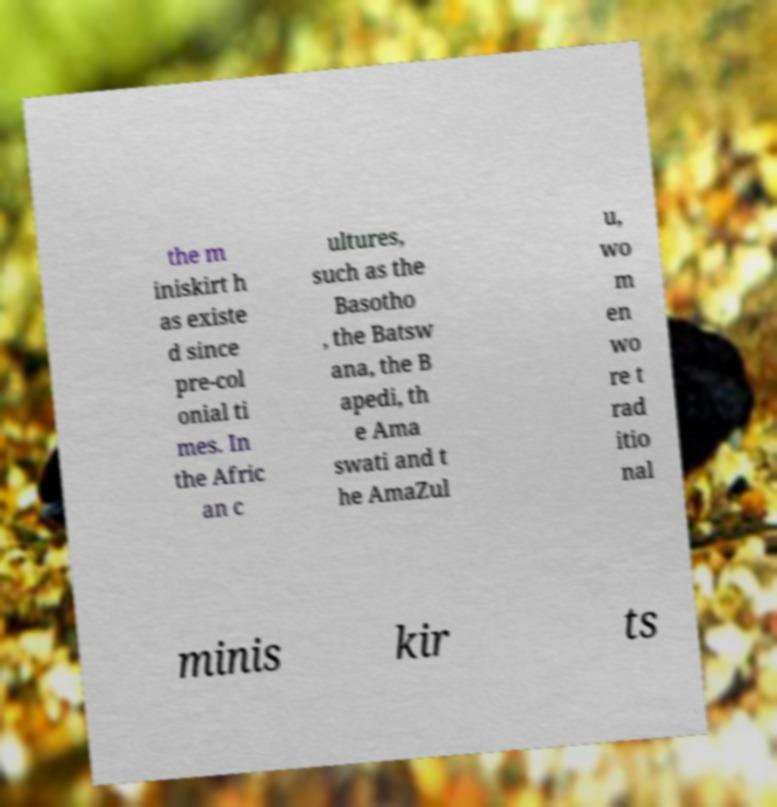What messages or text are displayed in this image? I need them in a readable, typed format. the m iniskirt h as existe d since pre-col onial ti mes. In the Afric an c ultures, such as the Basotho , the Batsw ana, the B apedi, th e Ama swati and t he AmaZul u, wo m en wo re t rad itio nal minis kir ts 